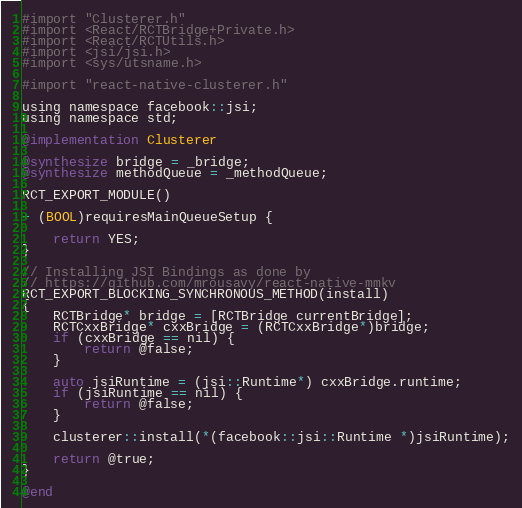Convert code to text. <code><loc_0><loc_0><loc_500><loc_500><_ObjectiveC_>#import "Clusterer.h"
#import <React/RCTBridge+Private.h>
#import <React/RCTUtils.h>
#import <jsi/jsi.h>
#import <sys/utsname.h>

#import "react-native-clusterer.h"

using namespace facebook::jsi;
using namespace std;

@implementation Clusterer

@synthesize bridge = _bridge;
@synthesize methodQueue = _methodQueue;

RCT_EXPORT_MODULE()

+ (BOOL)requiresMainQueueSetup {
    
    return YES;
}

// Installing JSI Bindings as done by
// https://github.com/mrousavy/react-native-mmkv
RCT_EXPORT_BLOCKING_SYNCHRONOUS_METHOD(install)
{
    RCTBridge* bridge = [RCTBridge currentBridge];
    RCTCxxBridge* cxxBridge = (RCTCxxBridge*)bridge;
    if (cxxBridge == nil) {
        return @false;
    }

    auto jsiRuntime = (jsi::Runtime*) cxxBridge.runtime;
    if (jsiRuntime == nil) {
        return @false;
    }

    clusterer::install(*(facebook::jsi::Runtime *)jsiRuntime);

    return @true;
}

@end
</code> 